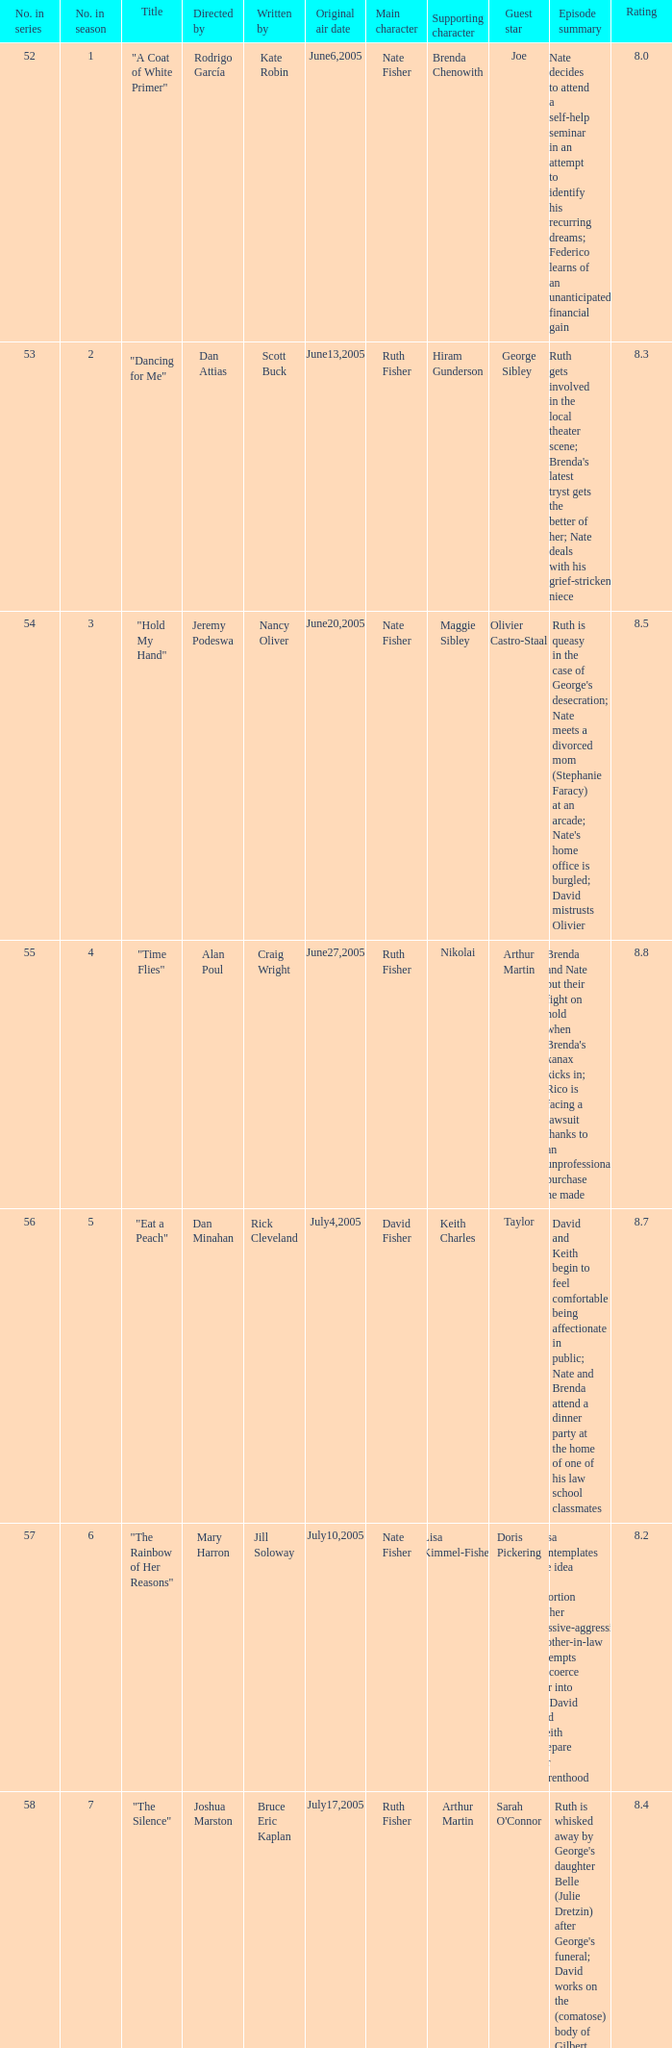What date was episode 10 in the season originally aired? August7,2005. 